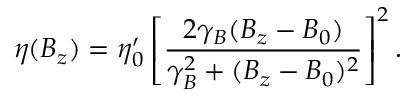Convert formula to latex. <formula><loc_0><loc_0><loc_500><loc_500>\eta ( B _ { z } ) = \eta _ { 0 } ^ { \prime } \left [ \frac { 2 \gamma _ { B } ( B _ { z } - B _ { 0 } ) } { \gamma _ { B } ^ { 2 } + ( B _ { z } - B _ { 0 } ) ^ { 2 } } \right ] ^ { 2 } .</formula> 